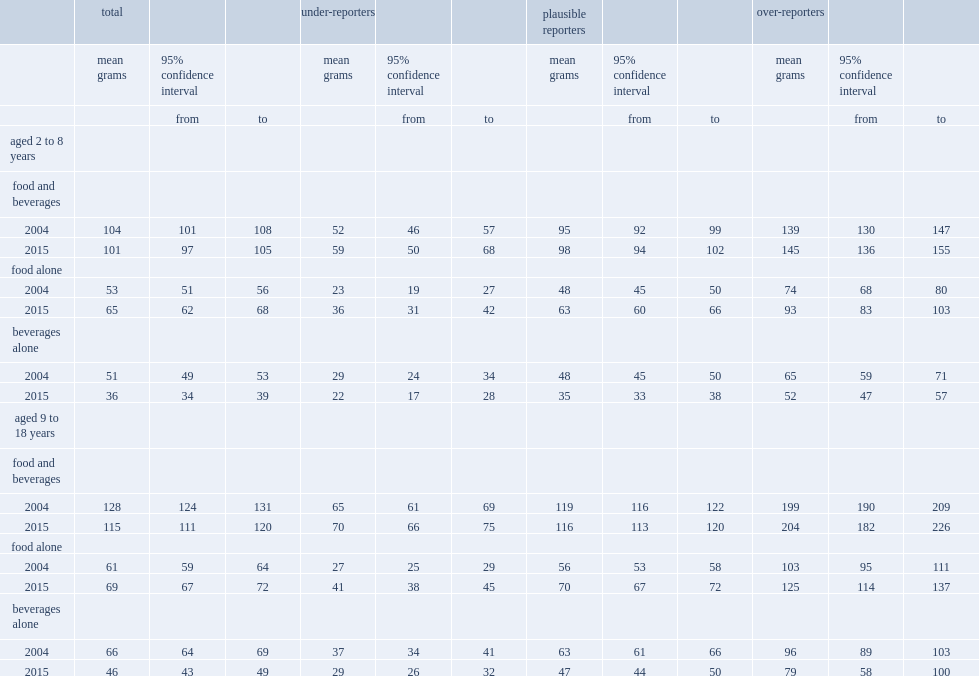What is the average daily total sugars intake from food and beverages among all children aged 2 to 8. 101. In 2015, what is the average grams of sugar that consumed by children aged 2 to 8, among the plausible respondents? 98. What is the average daily total sugars intake from food and beverages for children aged 9 to 18 in 2015. 115. For children aged 9 to 18, what is the average daily sugars intake from food and beverages among thoes plausible reporters in 2015? 116. For children aged 9 to 18, which year has a lower overall daily total sugars intake, 2004 or 2015? 2015. Give me the full table as a dictionary. {'header': ['', 'total', '', '', 'under-reporters', '', '', 'plausible reporters', '', '', 'over-reporters', '', ''], 'rows': [['', 'mean grams', '95% confidence interval', '', 'mean grams', '95% confidence interval', '', 'mean grams', '95% confidence interval', '', 'mean grams', '95% confidence interval', ''], ['', '', 'from', 'to', '', 'from', 'to', '', 'from', 'to', '', 'from', 'to'], ['aged 2 to 8 years', '', '', '', '', '', '', '', '', '', '', '', ''], ['food and beverages', '', '', '', '', '', '', '', '', '', '', '', ''], ['2004', '104', '101', '108', '52', '46', '57', '95', '92', '99', '139', '130', '147'], ['2015', '101', '97', '105', '59', '50', '68', '98', '94', '102', '145', '136', '155'], ['food alone', '', '', '', '', '', '', '', '', '', '', '', ''], ['2004', '53', '51', '56', '23', '19', '27', '48', '45', '50', '74', '68', '80'], ['2015', '65', '62', '68', '36', '31', '42', '63', '60', '66', '93', '83', '103'], ['beverages alone', '', '', '', '', '', '', '', '', '', '', '', ''], ['2004', '51', '49', '53', '29', '24', '34', '48', '45', '50', '65', '59', '71'], ['2015', '36', '34', '39', '22', '17', '28', '35', '33', '38', '52', '47', '57'], ['aged 9 to 18 years', '', '', '', '', '', '', '', '', '', '', '', ''], ['food and beverages', '', '', '', '', '', '', '', '', '', '', '', ''], ['2004', '128', '124', '131', '65', '61', '69', '119', '116', '122', '199', '190', '209'], ['2015', '115', '111', '120', '70', '66', '75', '116', '113', '120', '204', '182', '226'], ['food alone', '', '', '', '', '', '', '', '', '', '', '', ''], ['2004', '61', '59', '64', '27', '25', '29', '56', '53', '58', '103', '95', '111'], ['2015', '69', '67', '72', '41', '38', '45', '70', '67', '72', '125', '114', '137'], ['beverages alone', '', '', '', '', '', '', '', '', '', '', '', ''], ['2004', '66', '64', '69', '37', '34', '41', '63', '61', '66', '96', '89', '103'], ['2015', '46', '43', '49', '29', '26', '32', '47', '44', '50', '79', '58', '100']]} 